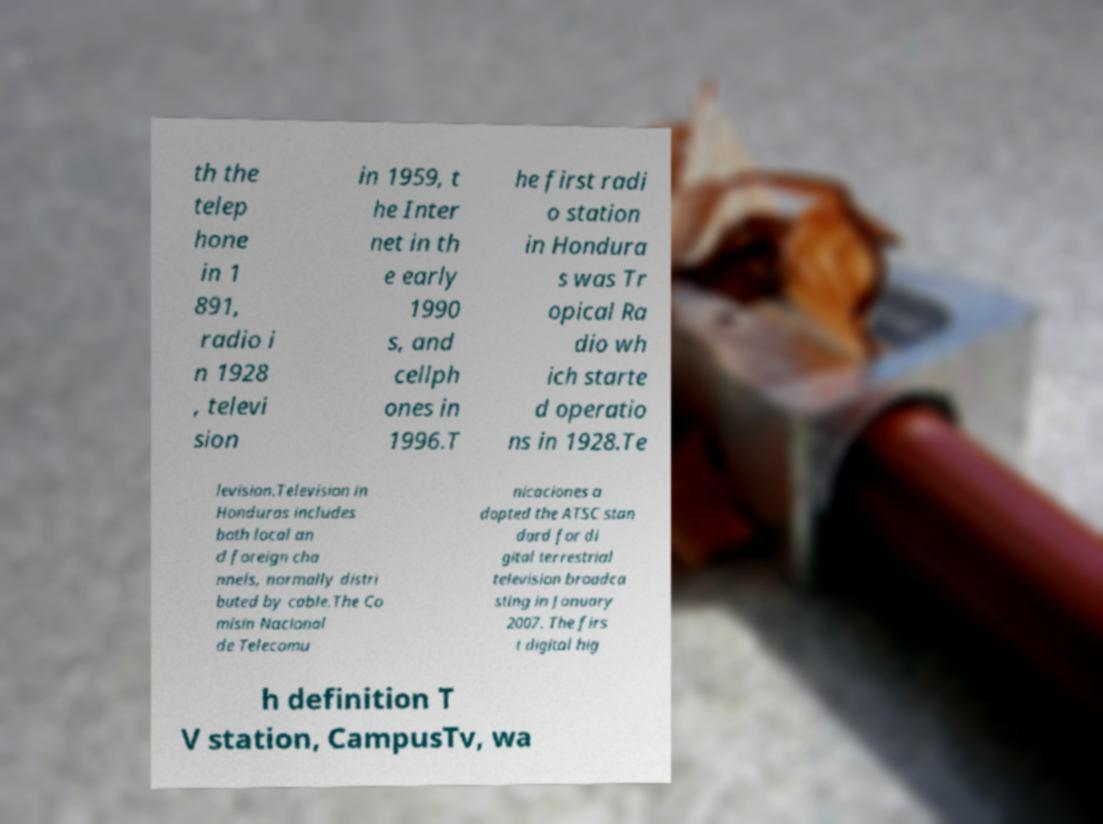I need the written content from this picture converted into text. Can you do that? th the telep hone in 1 891, radio i n 1928 , televi sion in 1959, t he Inter net in th e early 1990 s, and cellph ones in 1996.T he first radi o station in Hondura s was Tr opical Ra dio wh ich starte d operatio ns in 1928.Te levision.Television in Honduras includes both local an d foreign cha nnels, normally distri buted by cable.The Co misin Nacional de Telecomu nicaciones a dopted the ATSC stan dard for di gital terrestrial television broadca sting in January 2007. The firs t digital hig h definition T V station, CampusTv, wa 